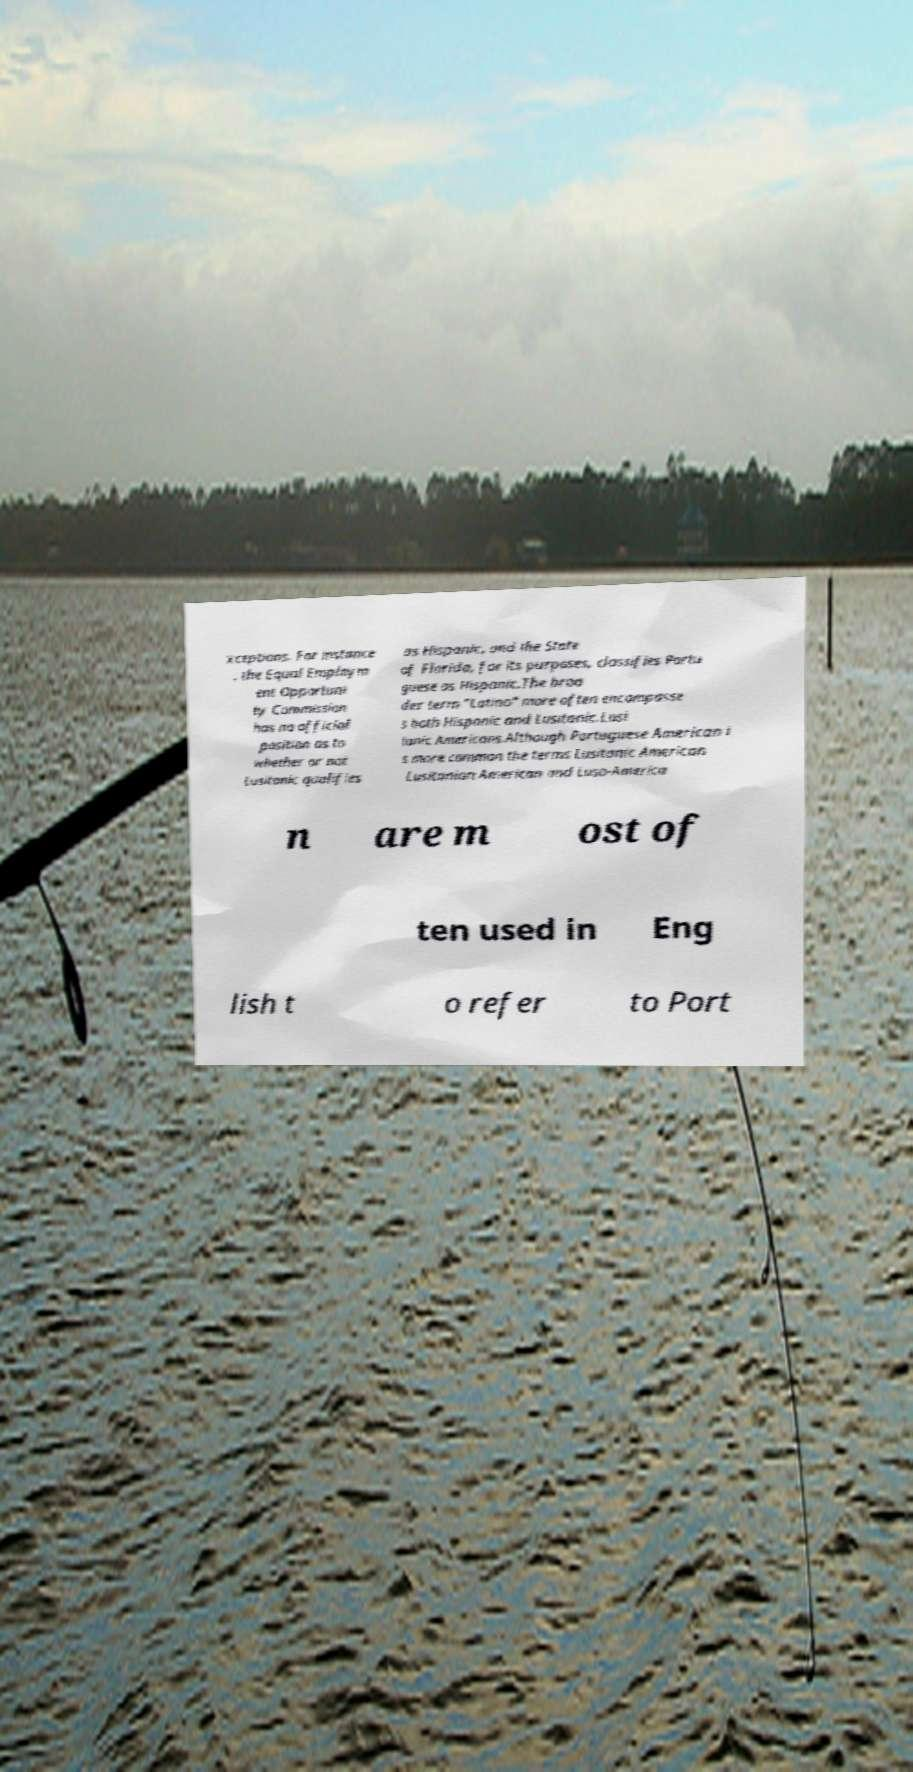Could you extract and type out the text from this image? xceptions. For instance , the Equal Employm ent Opportuni ty Commission has no official position as to whether or not Lusitanic qualifies as Hispanic, and the State of Florida, for its purposes, classifies Portu guese as Hispanic.The broa der term "Latino" more often encompasse s both Hispanic and Lusitanic.Lusi tanic Americans.Although Portuguese American i s more common the terms Lusitanic American Lusitanian American and Luso-America n are m ost of ten used in Eng lish t o refer to Port 